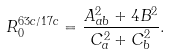Convert formula to latex. <formula><loc_0><loc_0><loc_500><loc_500>R _ { 0 } ^ { 6 3 c / 1 7 c } = \frac { A _ { a b } ^ { 2 } + 4 B ^ { 2 } } { C _ { a } ^ { 2 } + C _ { b } ^ { 2 } } .</formula> 